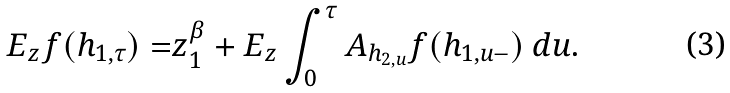<formula> <loc_0><loc_0><loc_500><loc_500>E _ { z } f ( h _ { 1 , \tau } ) = & z _ { 1 } ^ { \beta } + E _ { z } \int _ { 0 } ^ { \tau } A _ { h _ { 2 , u } } f ( h _ { 1 , u - } ) \ d u .</formula> 